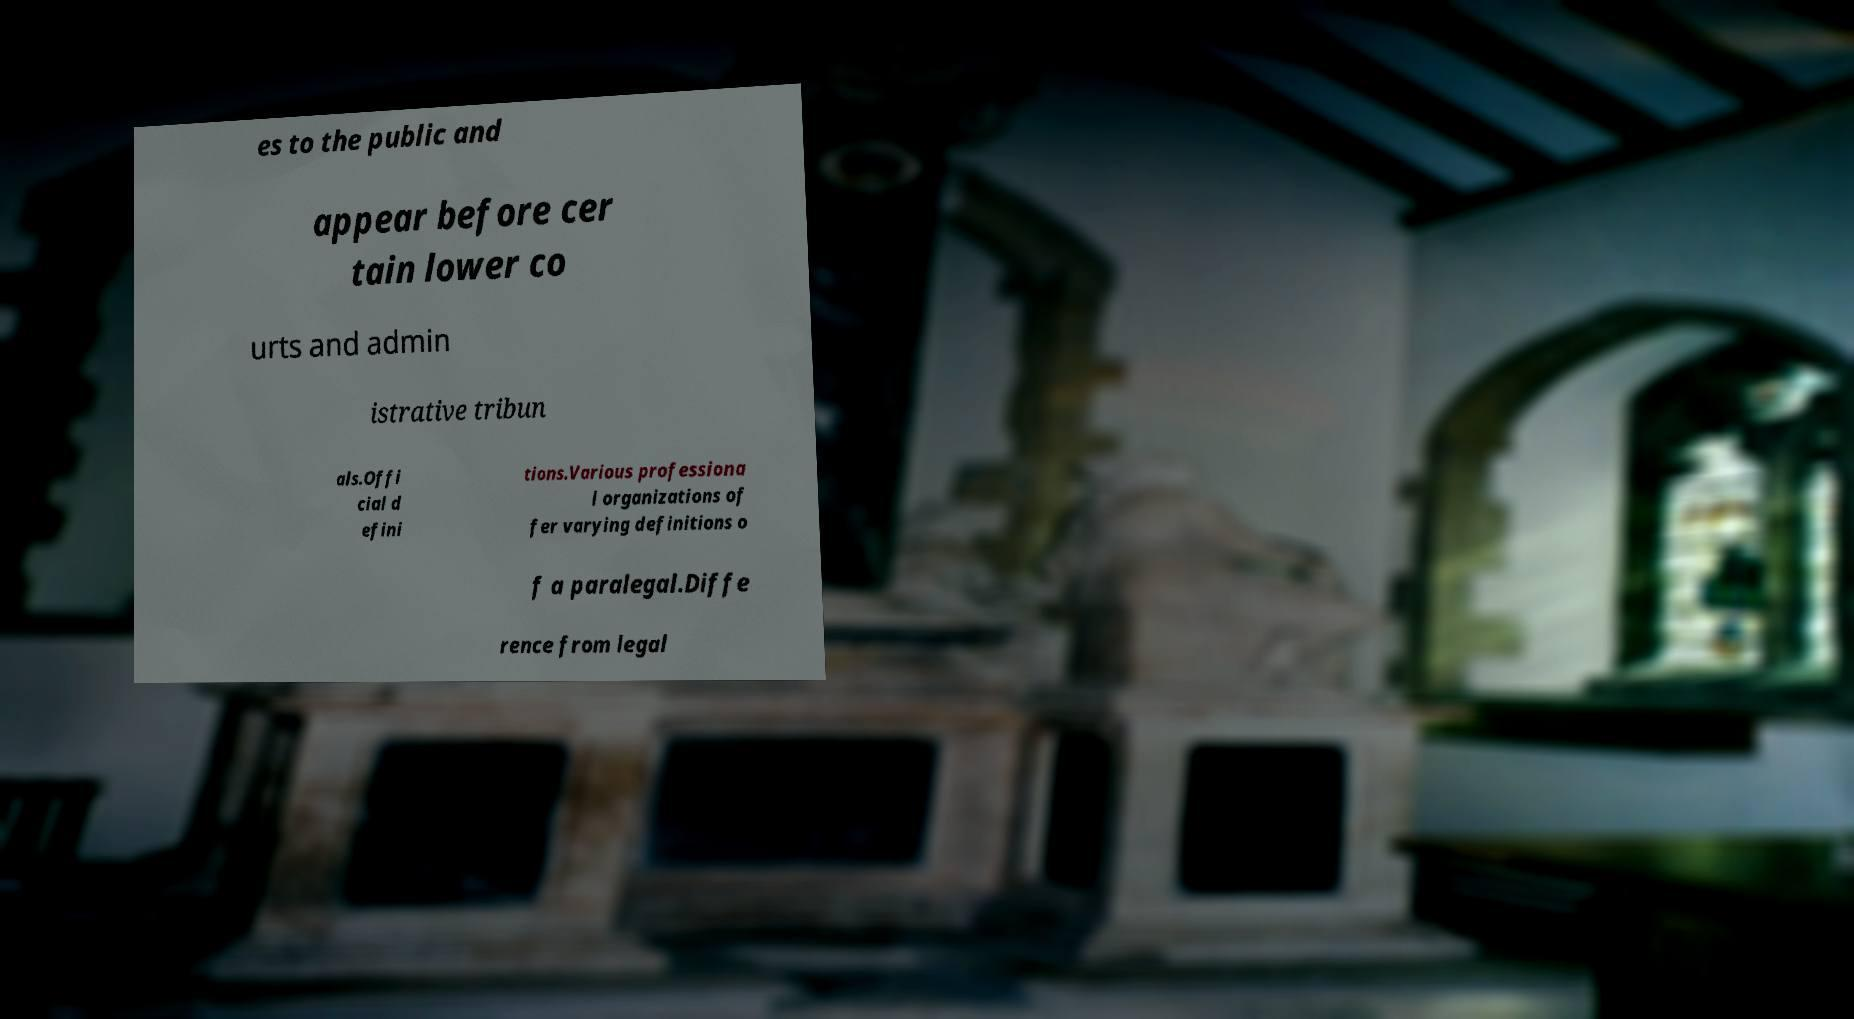Could you extract and type out the text from this image? es to the public and appear before cer tain lower co urts and admin istrative tribun als.Offi cial d efini tions.Various professiona l organizations of fer varying definitions o f a paralegal.Diffe rence from legal 